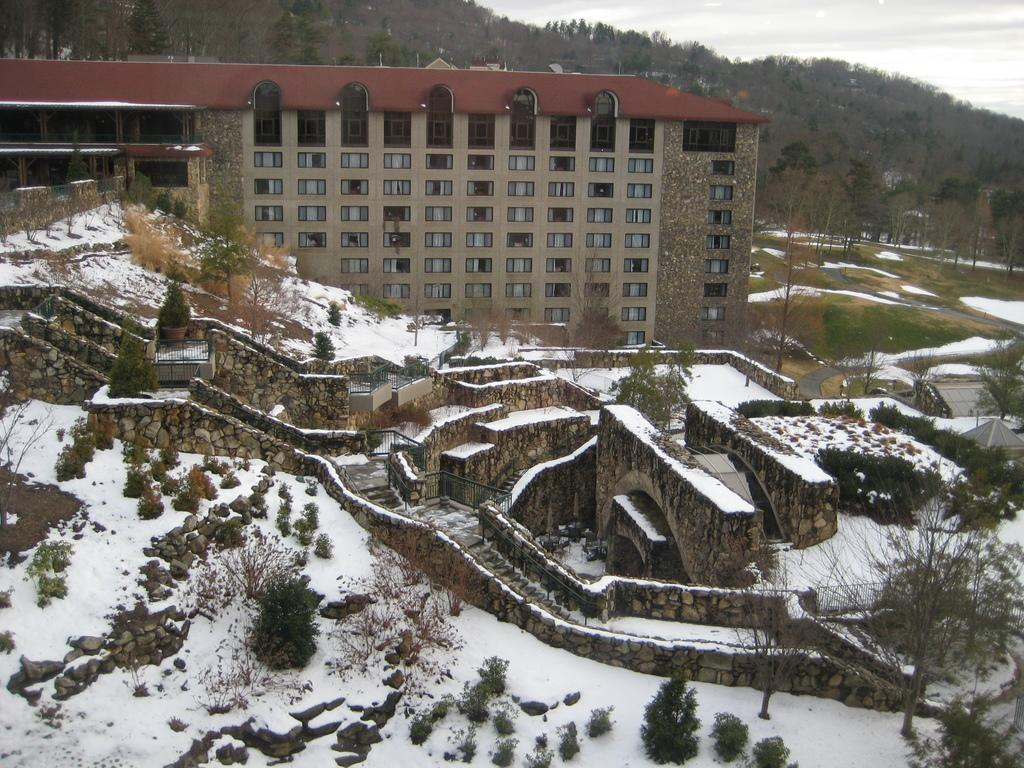What type of structure is in the image? There is a building in the image. What feature of the building is mentioned in the facts? The building has windows. What architectural element can be seen in the image? There are stairs in the image. What type of material is present in the image? Stones are present in the image. What type of barrier is in the image? There is a fence in the image. What type of vegetation is visible in the image? Grass is visible in the image. What geographical feature is in the background of the image? There is a hill in the background of the image. What type of natural elements are in the background of the image? Trees and the sky are visible in the background of the image. How would you describe the sky in the image? The sky appears to be cloudy in the image. What is the chance of the toe being bitten by a snake in the image? There is no mention of a toe or a snake in the image, so it is not possible to determine the chance of a toe being bitten by a snake. 